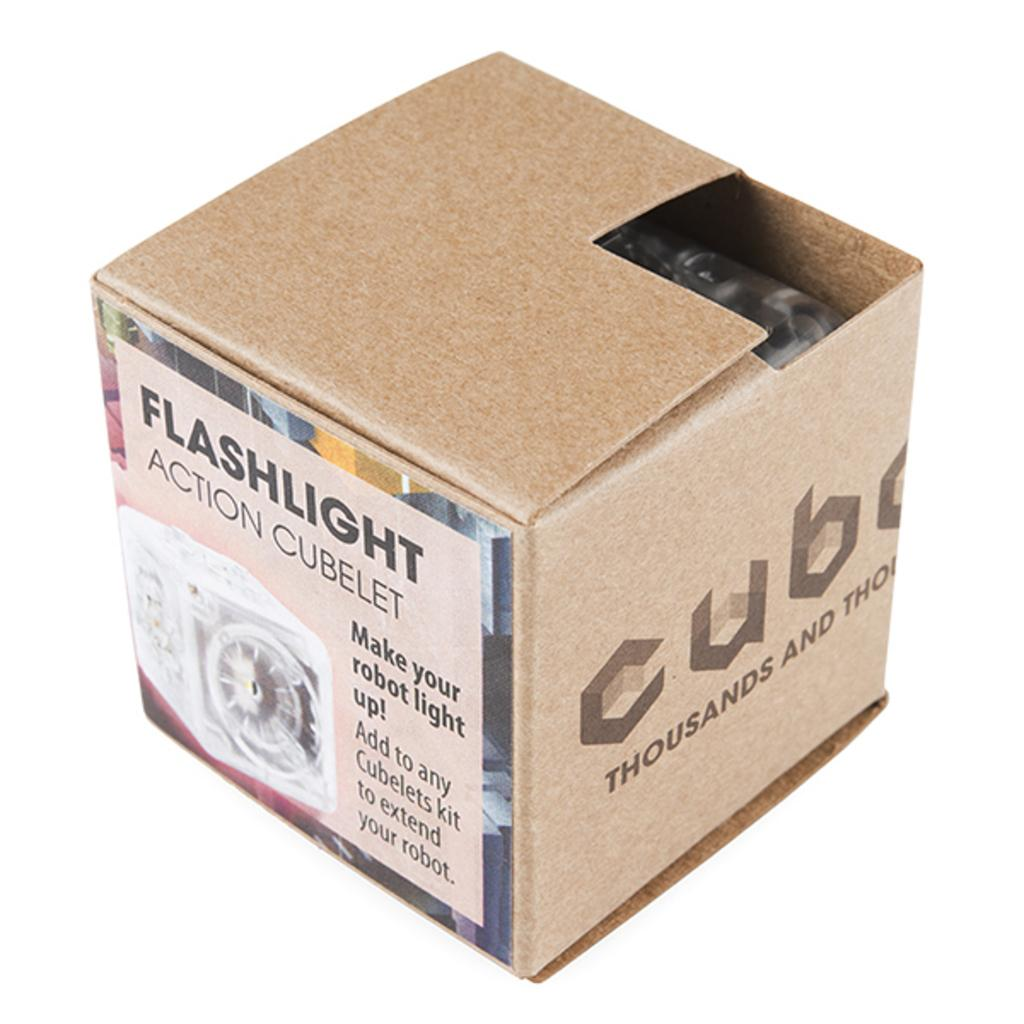<image>
Write a terse but informative summary of the picture. A box with "Flashlight Action Cubelet" written on it. 